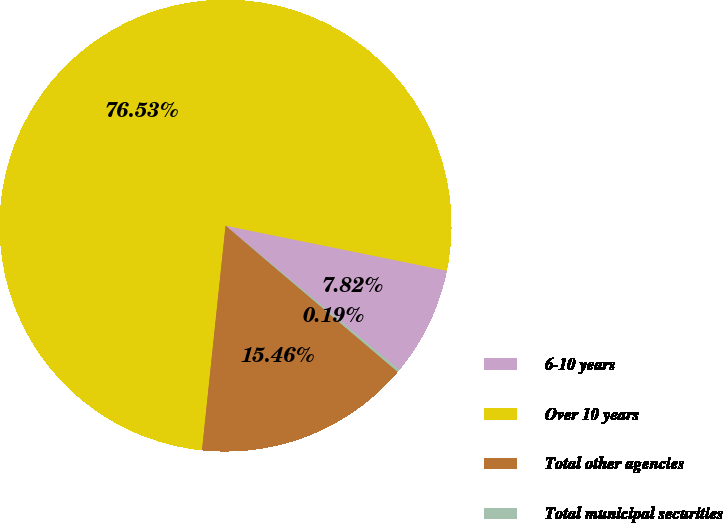Convert chart to OTSL. <chart><loc_0><loc_0><loc_500><loc_500><pie_chart><fcel>6-10 years<fcel>Over 10 years<fcel>Total other agencies<fcel>Total municipal securities<nl><fcel>7.82%<fcel>76.54%<fcel>15.46%<fcel>0.19%<nl></chart> 